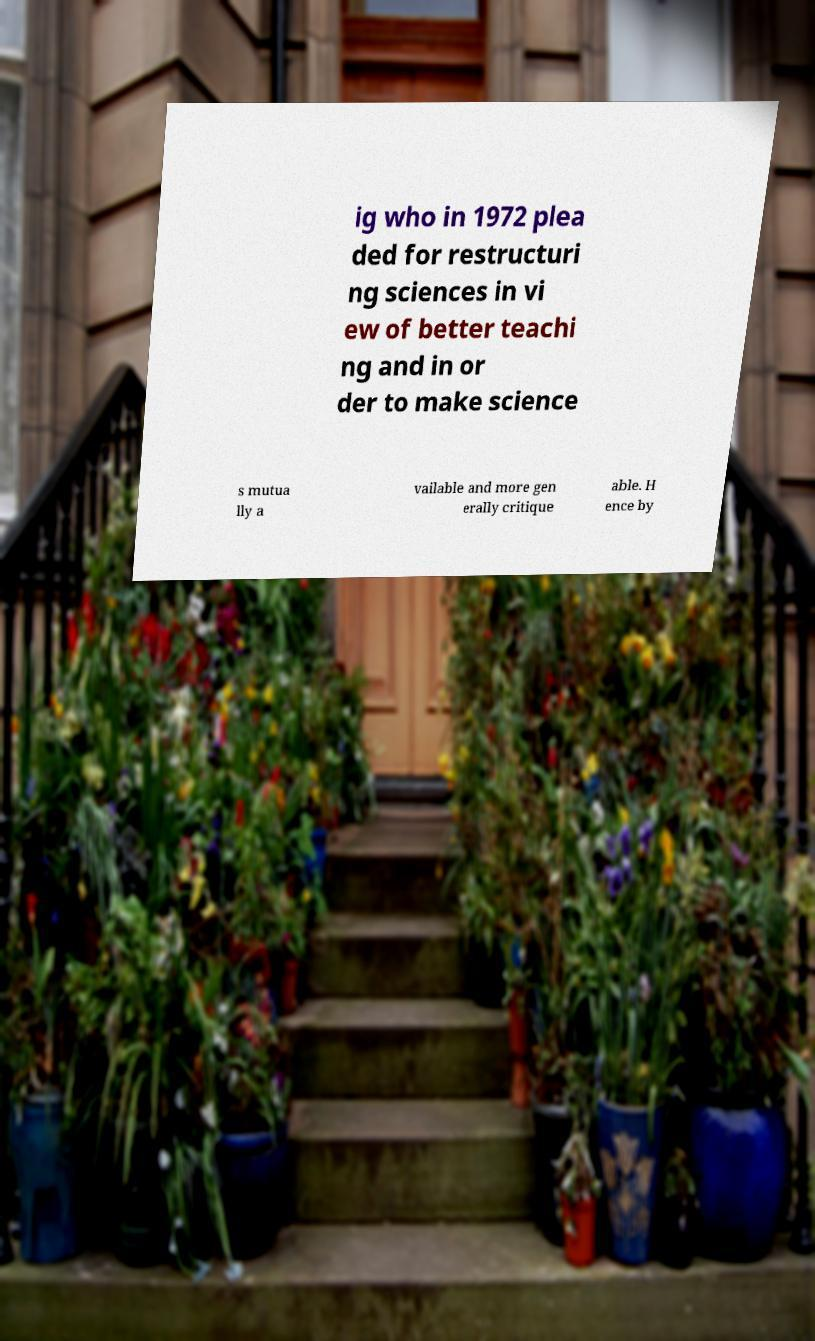Please read and relay the text visible in this image. What does it say? ig who in 1972 plea ded for restructuri ng sciences in vi ew of better teachi ng and in or der to make science s mutua lly a vailable and more gen erally critique able. H ence by 